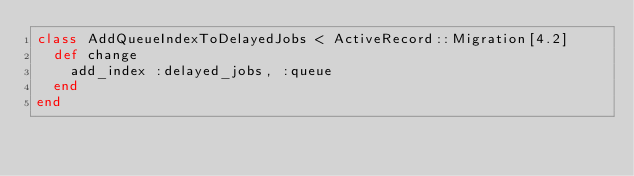<code> <loc_0><loc_0><loc_500><loc_500><_Ruby_>class AddQueueIndexToDelayedJobs < ActiveRecord::Migration[4.2]
  def change
    add_index :delayed_jobs, :queue
  end
end
</code> 